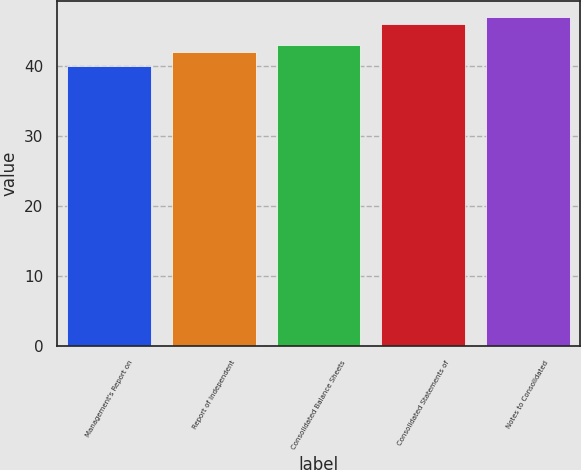<chart> <loc_0><loc_0><loc_500><loc_500><bar_chart><fcel>Management's Report on<fcel>Report of Independent<fcel>Consolidated Balance Sheets<fcel>Consolidated Statements of<fcel>Notes to Consolidated<nl><fcel>40<fcel>42<fcel>43<fcel>46<fcel>47<nl></chart> 